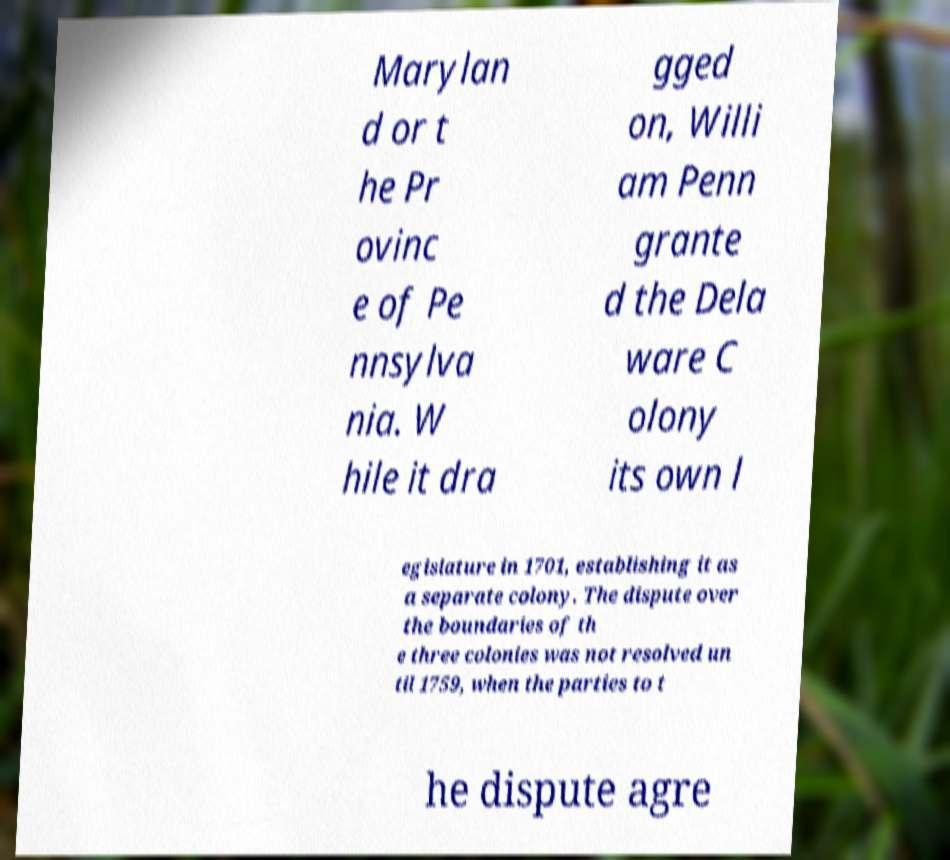Please identify and transcribe the text found in this image. Marylan d or t he Pr ovinc e of Pe nnsylva nia. W hile it dra gged on, Willi am Penn grante d the Dela ware C olony its own l egislature in 1701, establishing it as a separate colony. The dispute over the boundaries of th e three colonies was not resolved un til 1759, when the parties to t he dispute agre 